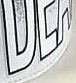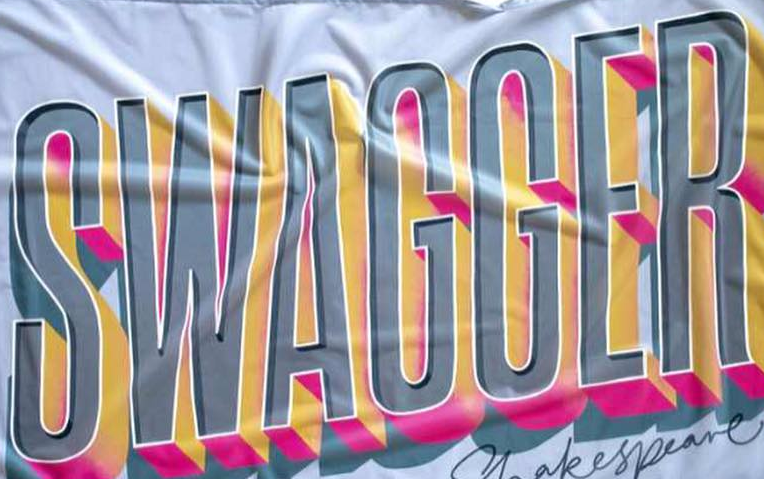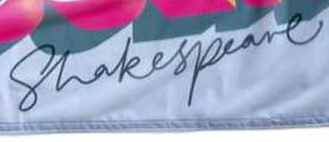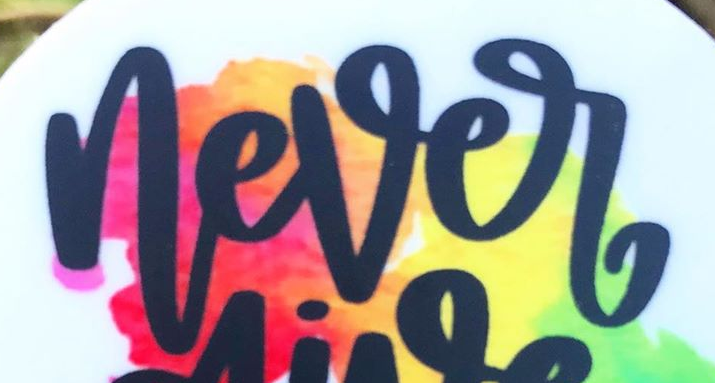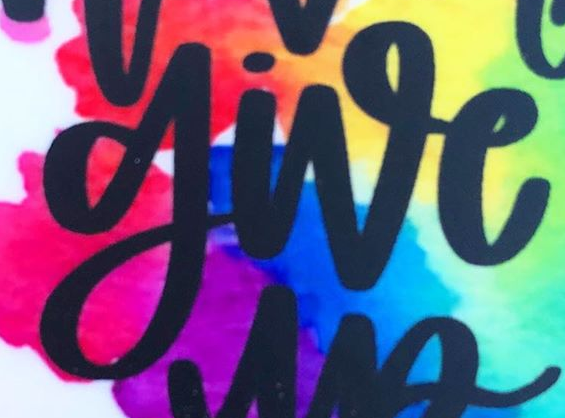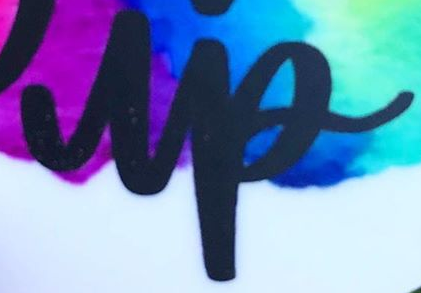Transcribe the words shown in these images in order, separated by a semicolon. ###; SWAGGER; Shakespeare; never; give; up 